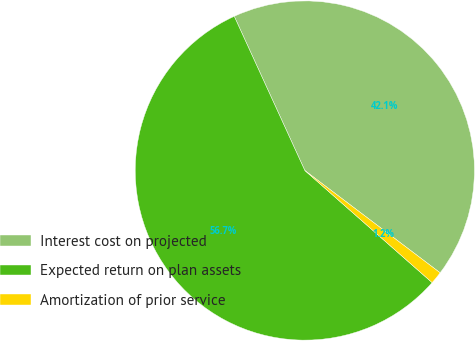Convert chart to OTSL. <chart><loc_0><loc_0><loc_500><loc_500><pie_chart><fcel>Interest cost on projected<fcel>Expected return on plan assets<fcel>Amortization of prior service<nl><fcel>42.14%<fcel>56.68%<fcel>1.19%<nl></chart> 